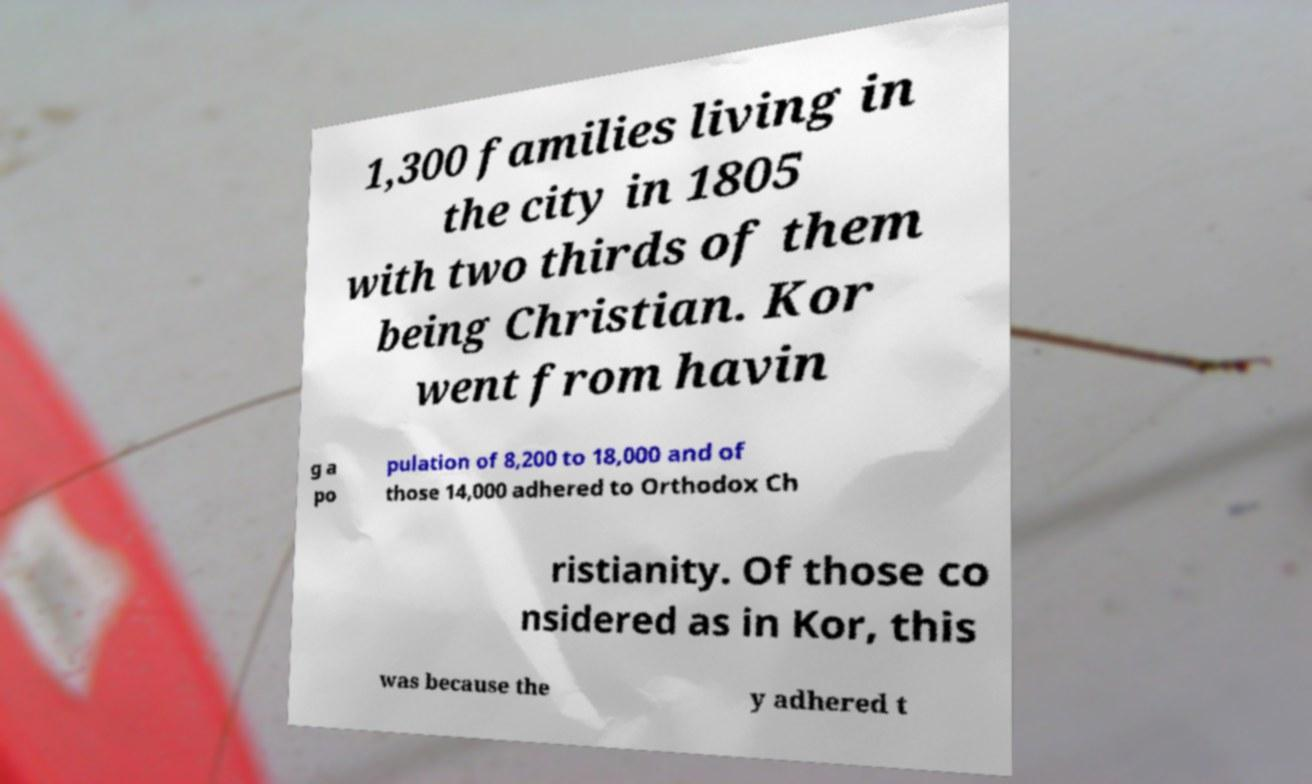What messages or text are displayed in this image? I need them in a readable, typed format. 1,300 families living in the city in 1805 with two thirds of them being Christian. Kor went from havin g a po pulation of 8,200 to 18,000 and of those 14,000 adhered to Orthodox Ch ristianity. Of those co nsidered as in Kor, this was because the y adhered t 